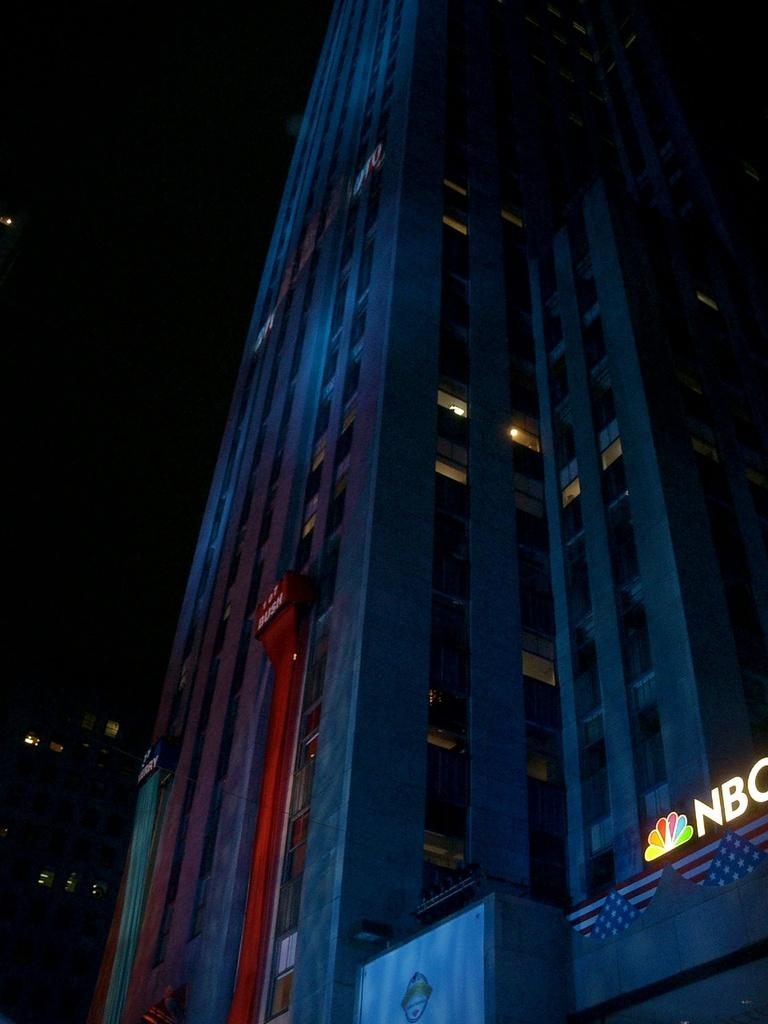What is the main subject of the image? The main subject of the image is a skyscraper. What specific features can be observed on the skyscraper? The skyscraper has windows. Is there any text visible on the skyscraper? Yes, text is visible on the windows of the skyscraper. What is the color of the background in the image? The background of the image is dark. Can you tell me how many grandmothers are sitting on the bridge in the image? There are no grandmothers or bridges present in the image; it features a skyscraper with text on its windows. What type of pipe is visible on the side of the skyscraper in the image? There is no pipe visible on the side of the skyscraper in the image. 